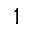<formula> <loc_0><loc_0><loc_500><loc_500>1</formula> 